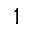<formula> <loc_0><loc_0><loc_500><loc_500>1</formula> 